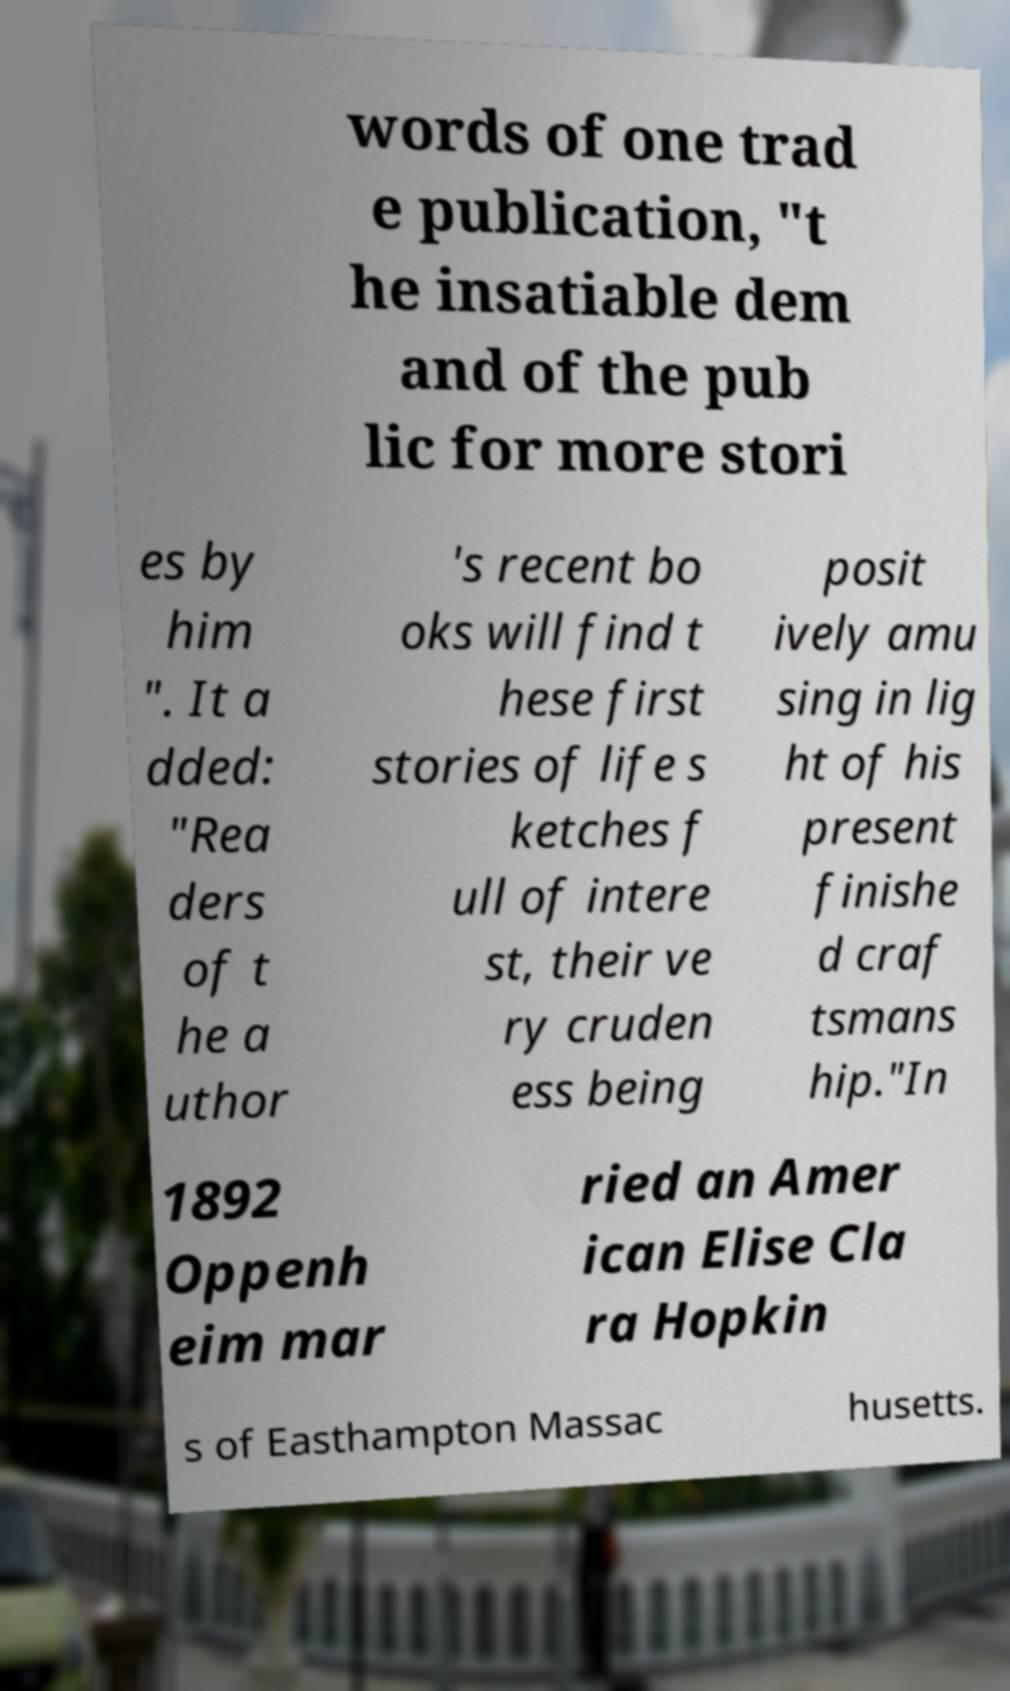For documentation purposes, I need the text within this image transcribed. Could you provide that? words of one trad e publication, "t he insatiable dem and of the pub lic for more stori es by him ". It a dded: "Rea ders of t he a uthor 's recent bo oks will find t hese first stories of life s ketches f ull of intere st, their ve ry cruden ess being posit ively amu sing in lig ht of his present finishe d craf tsmans hip."In 1892 Oppenh eim mar ried an Amer ican Elise Cla ra Hopkin s of Easthampton Massac husetts. 